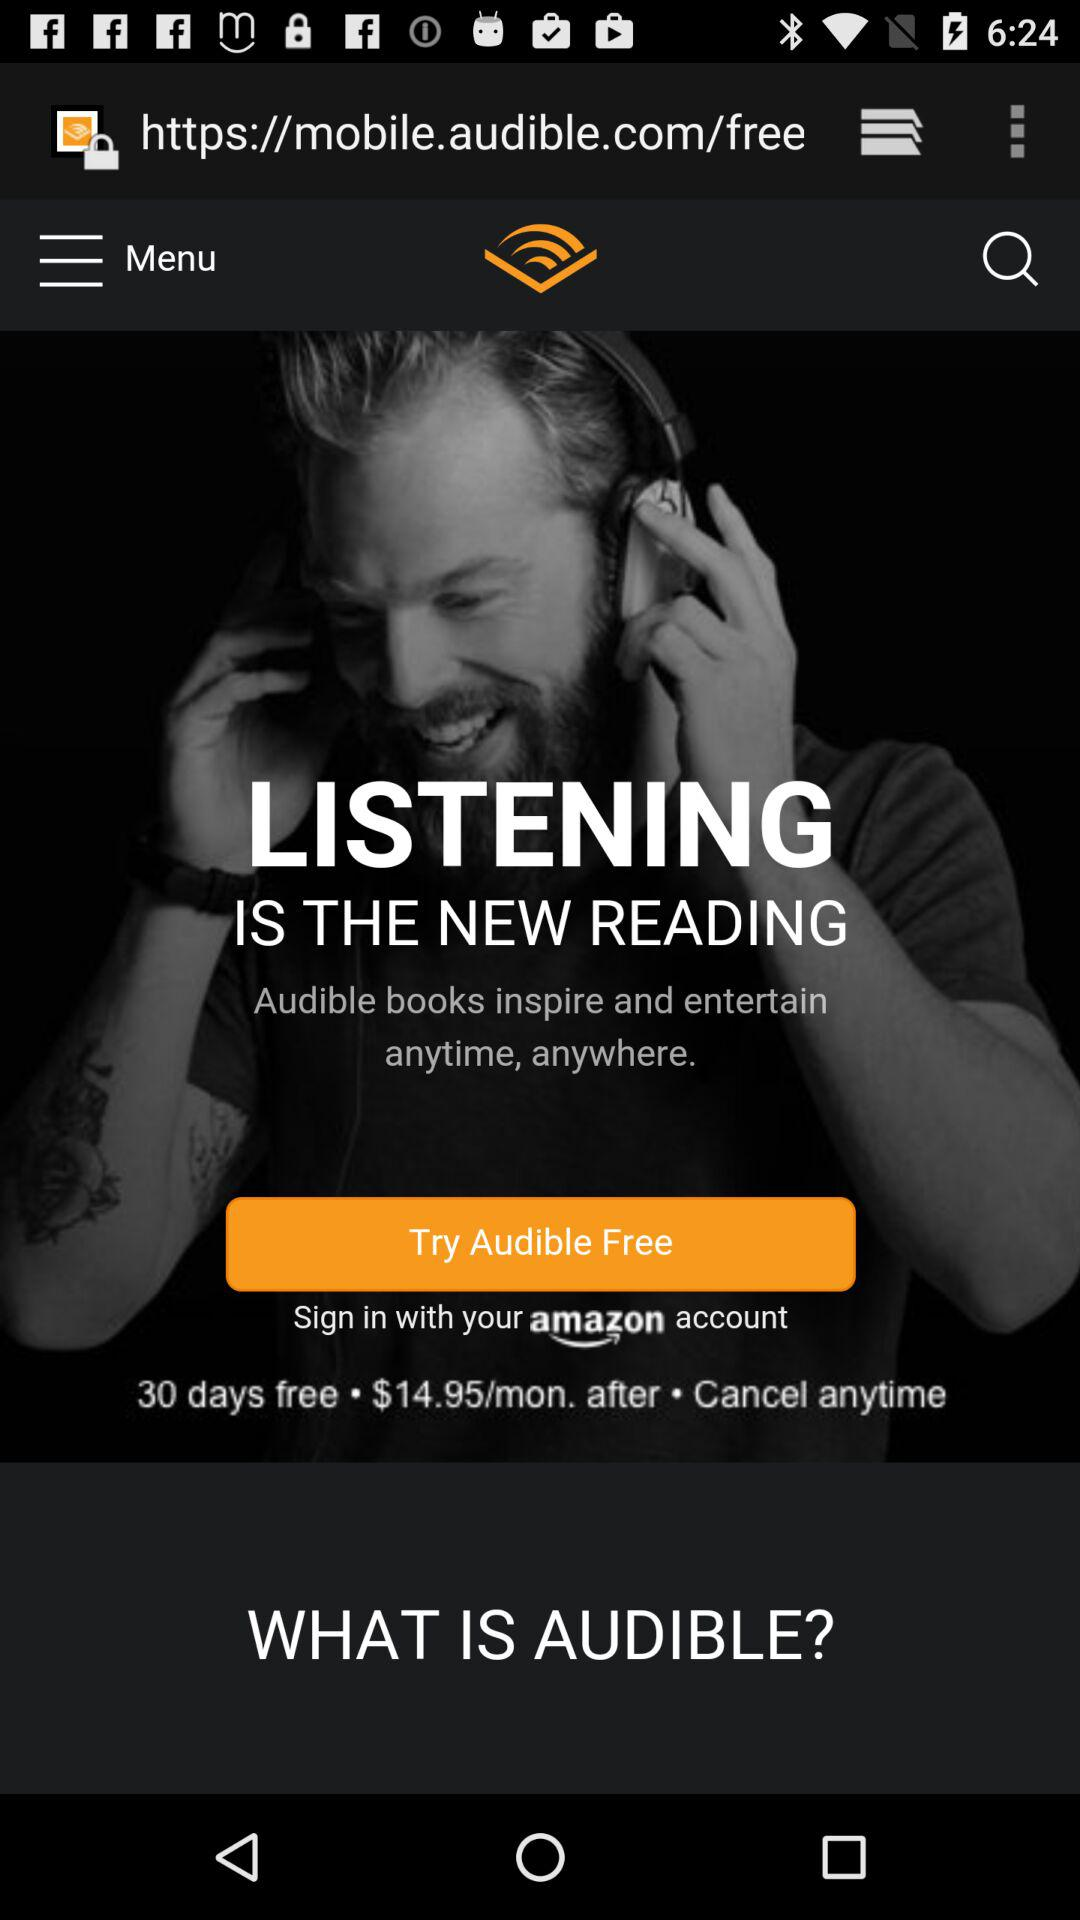How many more dollars per month will I pay after the 30-day free trial if I sign up for Audible?
Answer the question using a single word or phrase. $14.95 